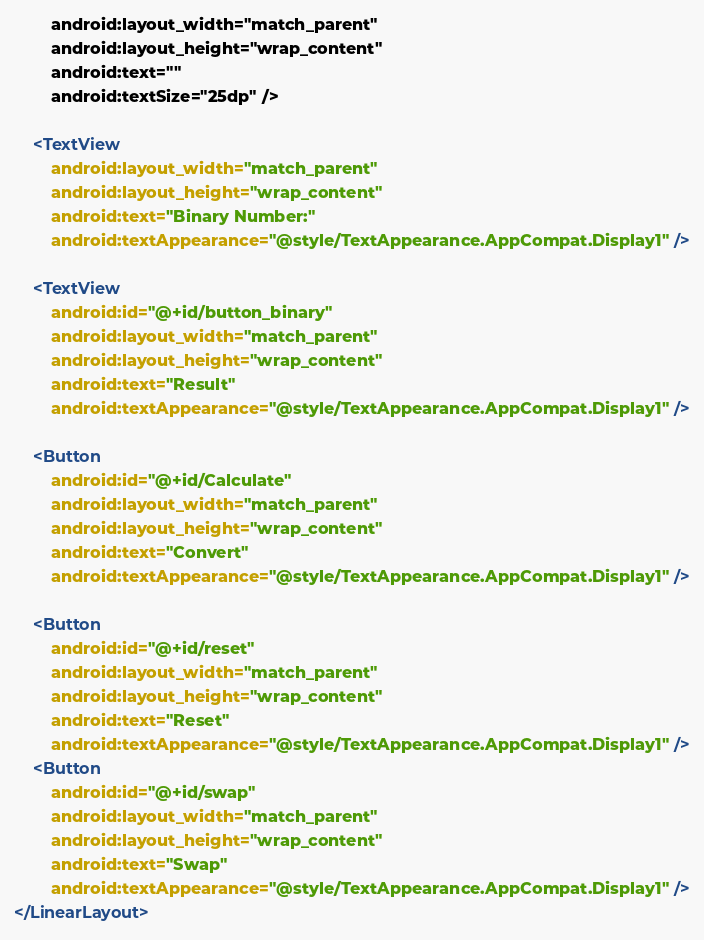<code> <loc_0><loc_0><loc_500><loc_500><_XML_>        android:layout_width="match_parent"
        android:layout_height="wrap_content"
        android:text=""
        android:textSize="25dp" />

    <TextView
        android:layout_width="match_parent"
        android:layout_height="wrap_content"
        android:text="Binary Number:"
        android:textAppearance="@style/TextAppearance.AppCompat.Display1" />

    <TextView
        android:id="@+id/button_binary"
        android:layout_width="match_parent"
        android:layout_height="wrap_content"
        android:text="Result"
        android:textAppearance="@style/TextAppearance.AppCompat.Display1" />

    <Button
        android:id="@+id/Calculate"
        android:layout_width="match_parent"
        android:layout_height="wrap_content"
        android:text="Convert"
        android:textAppearance="@style/TextAppearance.AppCompat.Display1" />

    <Button
        android:id="@+id/reset"
        android:layout_width="match_parent"
        android:layout_height="wrap_content"
        android:text="Reset"
        android:textAppearance="@style/TextAppearance.AppCompat.Display1" />
    <Button
        android:id="@+id/swap"
        android:layout_width="match_parent"
        android:layout_height="wrap_content"
        android:text="Swap"
        android:textAppearance="@style/TextAppearance.AppCompat.Display1" />
</LinearLayout></code> 